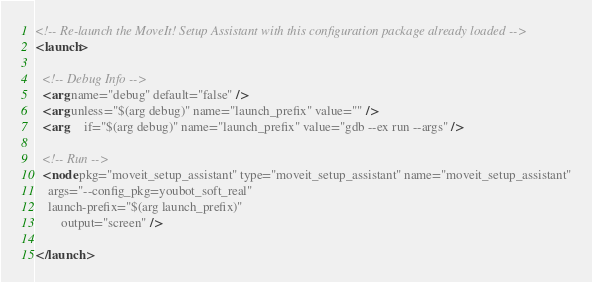<code> <loc_0><loc_0><loc_500><loc_500><_XML_><!-- Re-launch the MoveIt! Setup Assistant with this configuration package already loaded -->
<launch>

  <!-- Debug Info -->
  <arg name="debug" default="false" />
  <arg unless="$(arg debug)" name="launch_prefix" value="" />
  <arg     if="$(arg debug)" name="launch_prefix" value="gdb --ex run --args" />

  <!-- Run -->
  <node pkg="moveit_setup_assistant" type="moveit_setup_assistant" name="moveit_setup_assistant"
	args="--config_pkg=youbot_soft_real"
	launch-prefix="$(arg launch_prefix)"
        output="screen" />

</launch>
</code> 